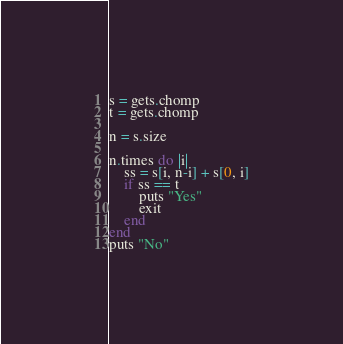Convert code to text. <code><loc_0><loc_0><loc_500><loc_500><_Ruby_>s = gets.chomp
t = gets.chomp

n = s.size

n.times do |i|
    ss = s[i, n-i] + s[0, i]
    if ss == t
        puts "Yes"
        exit
    end
end
puts "No"</code> 